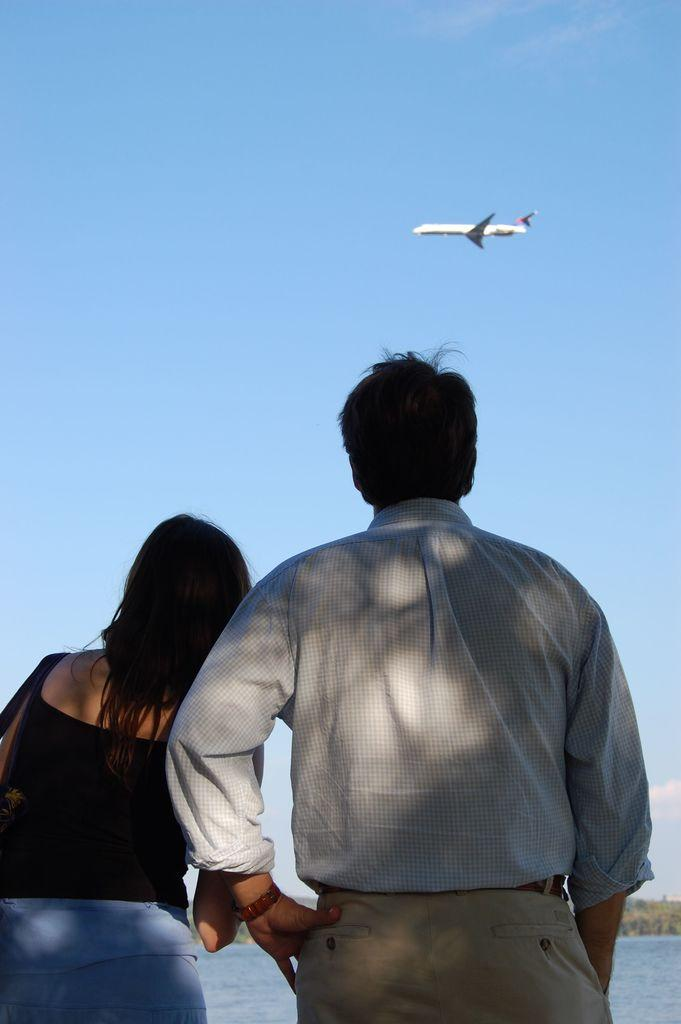Who are the people in the image? There is a man and a woman standing in the image. What can be seen in the background of the image? Water and an aeroplane flying in the sky are visible in the background of the image. What else is present in the sky in the background of the image? Clouds are present in the sky in the background of the image. What type of pear is being eaten in the lunchroom in the image? There is no pear or lunchroom present in the image. What is the nature of the love between the man and the woman in the image? The image does not provide any information about the relationship between the man and the woman, so it cannot be determined if they share any love. 